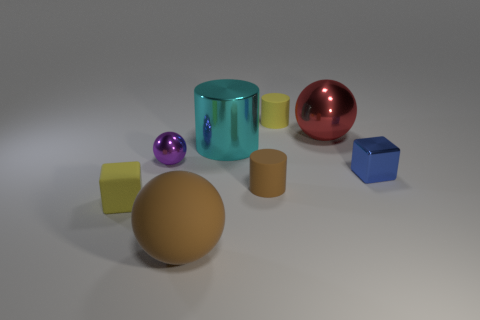Add 2 yellow matte blocks. How many objects exist? 10 Subtract all balls. How many objects are left? 5 Subtract all small cyan matte things. Subtract all big cyan metallic cylinders. How many objects are left? 7 Add 8 blue blocks. How many blue blocks are left? 9 Add 1 brown blocks. How many brown blocks exist? 1 Subtract 1 blue cubes. How many objects are left? 7 